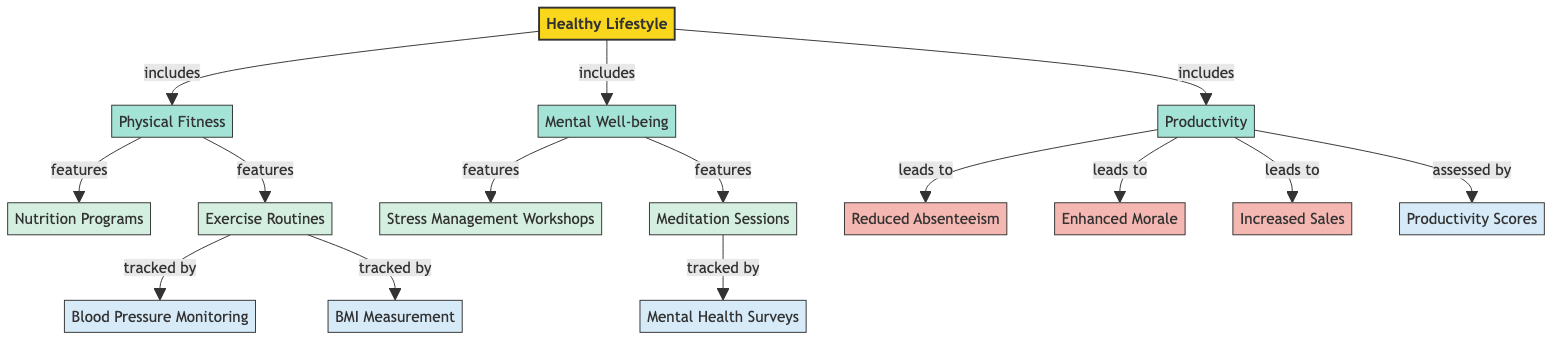What are the three categories included under a Healthy Lifestyle? The diagram specifically lists three categories under Healthy Lifestyle, which are Physical Fitness, Mental Well-being, and Productivity. These categories are directly connected to the Healthy Lifestyle node.
Answer: Physical Fitness, Mental Well-being, Productivity What features are listed under Physical Fitness? The diagram shows two features specifically under the Physical Fitness category, which are Nutrition Programs and Exercise Routines. These features are connected to the Physical Fitness node.
Answer: Nutrition Programs, Exercise Routines What is the impact associated with increased sales? The diagram indicates that increased sales is a result of the Productivity category, which leads to three impacts: Reduced Absenteeism, Enhanced Morale, and Increased Sales. Thus, Increased Sales is the name of one of the impacts listed.
Answer: Increased Sales How many metrics are used to track exercise routines? The diagram mentions two metrics that are tracked through the Exercise Routines category: Blood Pressure Monitoring and BMI Measurement. These two nodes are connected to the Exercise Routines node.
Answer: 2 Which workshops support mental well-being? The diagram identifies two workshops supporting Mental Well-being: Stress Management Workshops and Meditation Sessions. These workshops are directly linked to the Mental Well-being category of the diagram.
Answer: Stress Management Workshops, Meditation Sessions How does productivity lead to morale enhancement? The diagram specifies that the Productivity category leads to three impacts. One of these impacts is Enhanced Morale, which is directly indicated in the flow from Productivity to Enhanced Morale. Thus, Productivity leads to Enhanced Morale through this relationship.
Answer: Enhanced Morale What metrics are associated with mental health? According to the diagram, the metric associated with mental health is Mental Health Surveys which is connected to the Meditation Sessions as a trackable element. Therefore, Mental Health Surveys is the only metric represented for mental health evaluation.
Answer: Mental Health Surveys How many categories does a healthy lifestyle include? The Healthy Lifestyle includes three distinct categories as per the diagram: Physical Fitness, Mental Well-being, and Productivity. This counts as a direct look at the number of categories connected to the Healthy Lifestyle node.
Answer: 3 What is the role of exercise routines in this diagram? The Exercise Routines play a dual role in the diagram as both features under Physical Fitness and a contributor to tracked metrics such as Blood Pressure Monitoring and BMI Measurement. Thus, Exercise Routines function as a critical node for health improvement.
Answer: Features and Metrics 